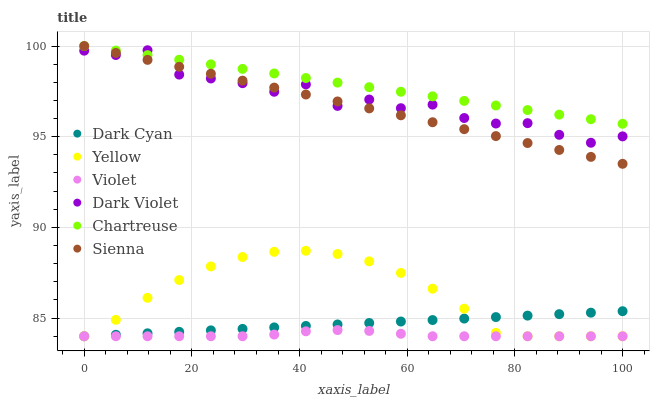Does Violet have the minimum area under the curve?
Answer yes or no. Yes. Does Chartreuse have the maximum area under the curve?
Answer yes or no. Yes. Does Sienna have the minimum area under the curve?
Answer yes or no. No. Does Sienna have the maximum area under the curve?
Answer yes or no. No. Is Dark Cyan the smoothest?
Answer yes or no. Yes. Is Dark Violet the roughest?
Answer yes or no. Yes. Is Sienna the smoothest?
Answer yes or no. No. Is Sienna the roughest?
Answer yes or no. No. Does Yellow have the lowest value?
Answer yes or no. Yes. Does Sienna have the lowest value?
Answer yes or no. No. Does Chartreuse have the highest value?
Answer yes or no. Yes. Does Yellow have the highest value?
Answer yes or no. No. Is Dark Cyan less than Chartreuse?
Answer yes or no. Yes. Is Chartreuse greater than Dark Cyan?
Answer yes or no. Yes. Does Yellow intersect Violet?
Answer yes or no. Yes. Is Yellow less than Violet?
Answer yes or no. No. Is Yellow greater than Violet?
Answer yes or no. No. Does Dark Cyan intersect Chartreuse?
Answer yes or no. No. 